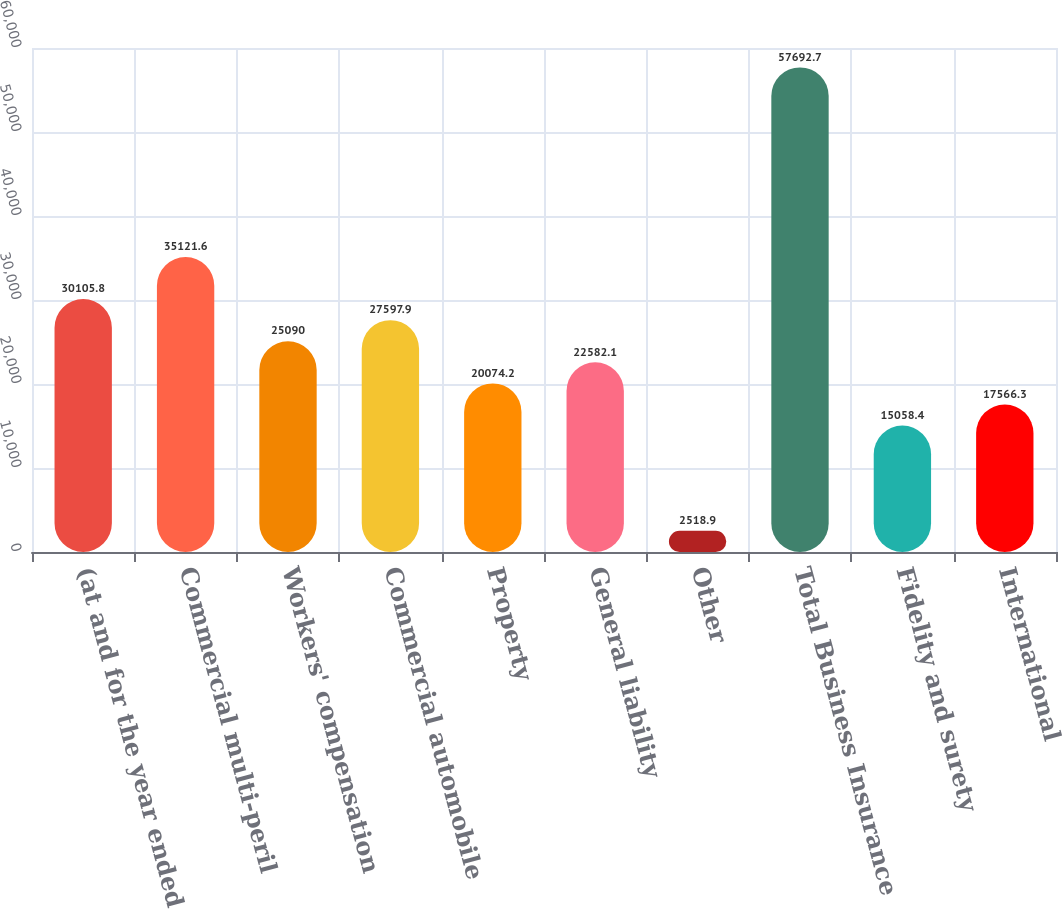<chart> <loc_0><loc_0><loc_500><loc_500><bar_chart><fcel>(at and for the year ended<fcel>Commercial multi-peril<fcel>Workers' compensation<fcel>Commercial automobile<fcel>Property<fcel>General liability<fcel>Other<fcel>Total Business Insurance<fcel>Fidelity and surety<fcel>International<nl><fcel>30105.8<fcel>35121.6<fcel>25090<fcel>27597.9<fcel>20074.2<fcel>22582.1<fcel>2518.9<fcel>57692.7<fcel>15058.4<fcel>17566.3<nl></chart> 